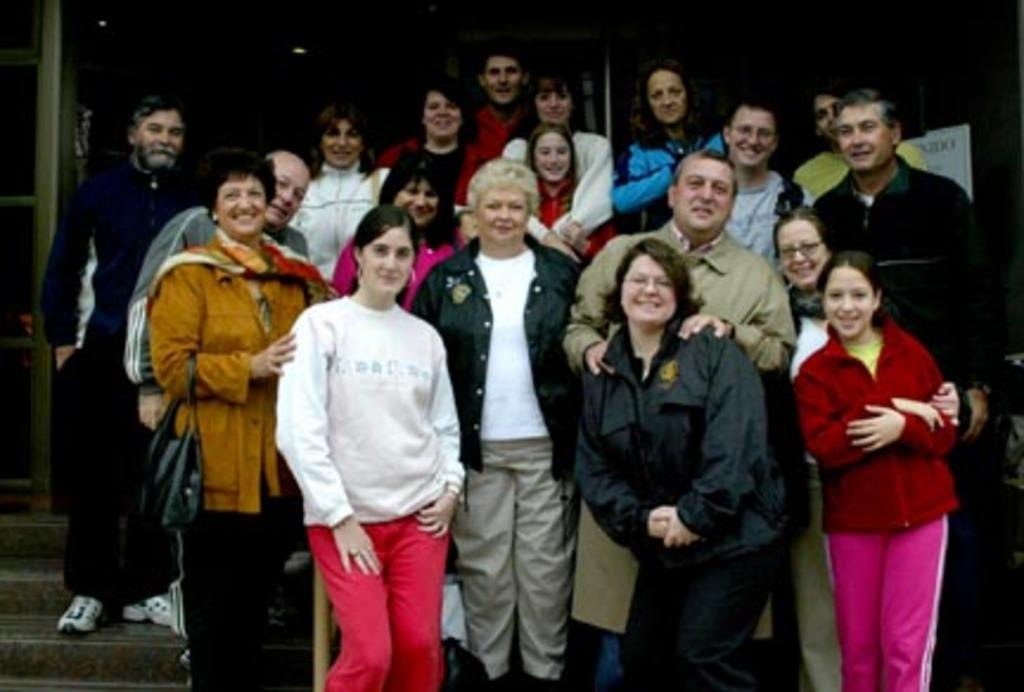What is the main subject of the image? The main subject of the image is a group of people. Can you describe the position of the people in the image? The people are standing in the center of the image. How are the people feeling, based on their facial expressions? The people are smiling, as indicated by their facial expressions. What can be seen in the background of the image? In the background of the image, there is a banner and a staircase. What type of clouds can be seen in the image? There are no clouds visible in the image. What color is the toothpaste being used by the people in the image? There is no toothpaste present in the image. 